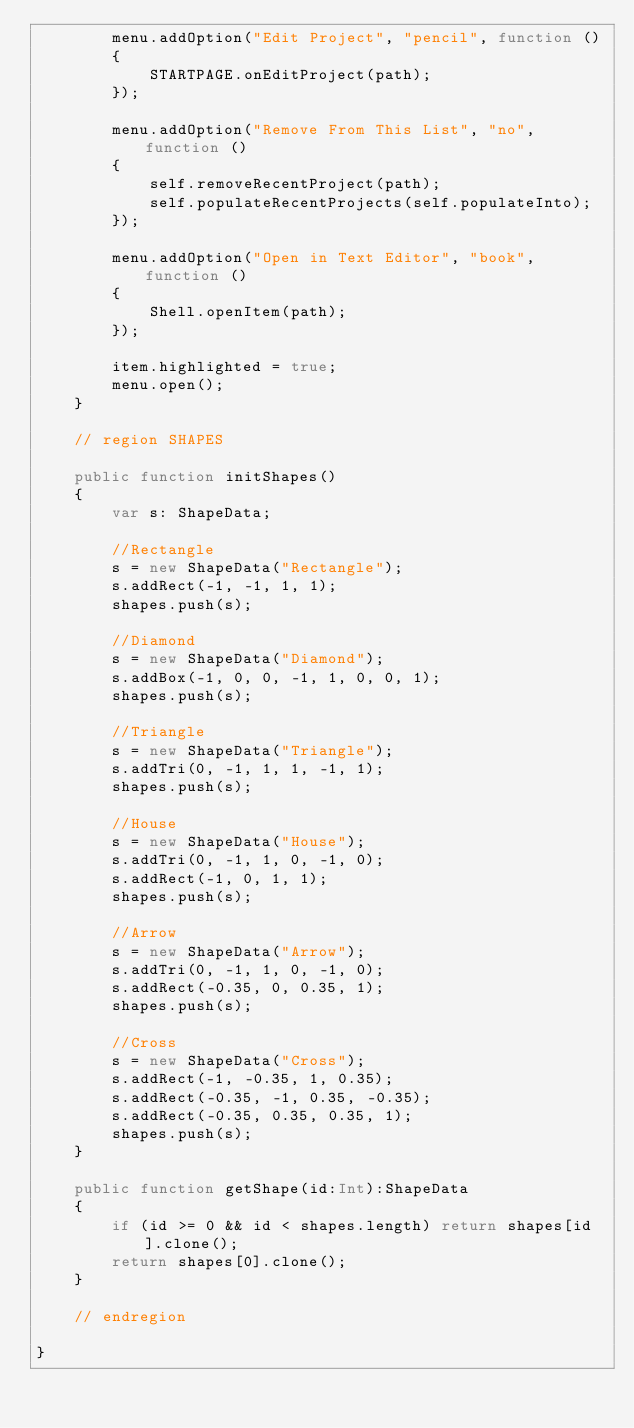Convert code to text. <code><loc_0><loc_0><loc_500><loc_500><_Haxe_>		menu.addOption("Edit Project", "pencil", function ()
		{
			STARTPAGE.onEditProject(path);
		});

		menu.addOption("Remove From This List", "no", function ()
		{
			self.removeRecentProject(path);
			self.populateRecentProjects(self.populateInto);
		});

		menu.addOption("Open in Text Editor", "book", function ()
		{
			Shell.openItem(path);
		});

		item.highlighted = true;
		menu.open();
	}

	// region SHAPES

	public function initShapes()
	{
		var s: ShapeData;

		//Rectangle
		s = new ShapeData("Rectangle");
		s.addRect(-1, -1, 1, 1);
		shapes.push(s);

		//Diamond
		s = new ShapeData("Diamond");
		s.addBox(-1, 0, 0, -1, 1, 0, 0, 1);
		shapes.push(s);

		//Triangle
		s = new ShapeData("Triangle");
		s.addTri(0, -1, 1, 1, -1, 1);
		shapes.push(s);

		//House
		s = new ShapeData("House");
		s.addTri(0, -1, 1, 0, -1, 0);
		s.addRect(-1, 0, 1, 1);
		shapes.push(s);

		//Arrow
		s = new ShapeData("Arrow");
		s.addTri(0, -1, 1, 0, -1, 0);
		s.addRect(-0.35, 0, 0.35, 1);
		shapes.push(s);

		//Cross
		s = new ShapeData("Cross");
		s.addRect(-1, -0.35, 1, 0.35);
		s.addRect(-0.35, -1, 0.35, -0.35);
		s.addRect(-0.35, 0.35, 0.35, 1);
		shapes.push(s);
	}

	public function getShape(id:Int):ShapeData
	{
		if (id >= 0 && id < shapes.length) return shapes[id].clone();
		return shapes[0].clone();
	}

	// endregion

}</code> 